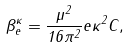Convert formula to latex. <formula><loc_0><loc_0><loc_500><loc_500>\beta _ { e } ^ { \kappa } = \frac { \mu ^ { 2 } } { 1 6 \pi ^ { 2 } } e \kappa ^ { 2 } C ,</formula> 